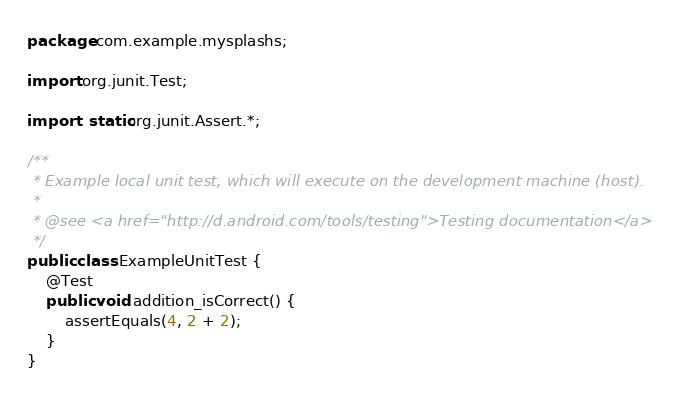<code> <loc_0><loc_0><loc_500><loc_500><_Java_>package com.example.mysplashs;

import org.junit.Test;

import static org.junit.Assert.*;

/**
 * Example local unit test, which will execute on the development machine (host).
 *
 * @see <a href="http://d.android.com/tools/testing">Testing documentation</a>
 */
public class ExampleUnitTest {
    @Test
    public void addition_isCorrect() {
        assertEquals(4, 2 + 2);
    }
}</code> 